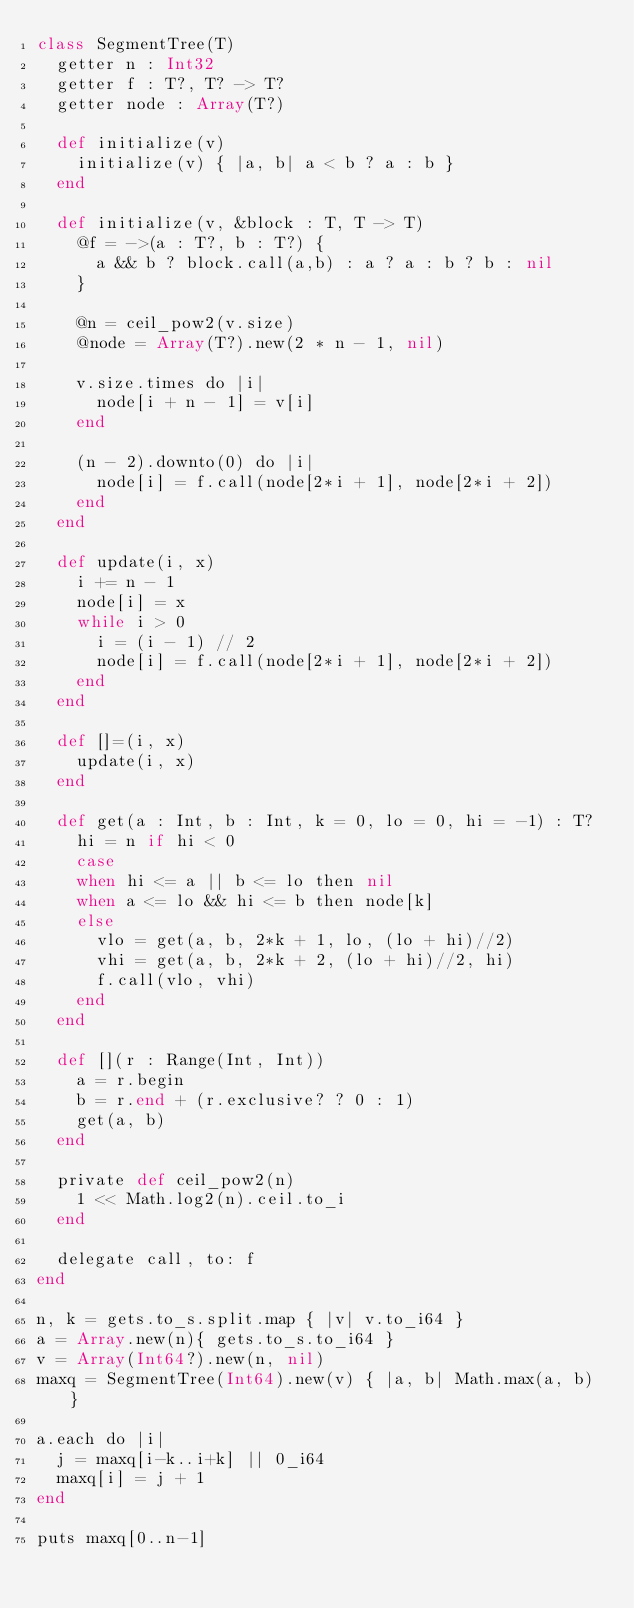Convert code to text. <code><loc_0><loc_0><loc_500><loc_500><_Crystal_>class SegmentTree(T)
  getter n : Int32
  getter f : T?, T? -> T?
  getter node : Array(T?)

  def initialize(v)
    initialize(v) { |a, b| a < b ? a : b }
  end

  def initialize(v, &block : T, T -> T)
    @f = ->(a : T?, b : T?) {
      a && b ? block.call(a,b) : a ? a : b ? b : nil
    }

    @n = ceil_pow2(v.size)
    @node = Array(T?).new(2 * n - 1, nil)

    v.size.times do |i|
      node[i + n - 1] = v[i]
    end

    (n - 2).downto(0) do |i|
      node[i] = f.call(node[2*i + 1], node[2*i + 2])
    end
  end

  def update(i, x)
    i += n - 1
    node[i] = x
    while i > 0
      i = (i - 1) // 2
      node[i] = f.call(node[2*i + 1], node[2*i + 2])
    end
  end

  def []=(i, x)
    update(i, x)
  end

  def get(a : Int, b : Int, k = 0, lo = 0, hi = -1) : T?
    hi = n if hi < 0
    case
    when hi <= a || b <= lo then nil
    when a <= lo && hi <= b then node[k]
    else
      vlo = get(a, b, 2*k + 1, lo, (lo + hi)//2)
      vhi = get(a, b, 2*k + 2, (lo + hi)//2, hi)
      f.call(vlo, vhi)
    end
  end

  def [](r : Range(Int, Int))
    a = r.begin
    b = r.end + (r.exclusive? ? 0 : 1)
    get(a, b)
  end

  private def ceil_pow2(n)
    1 << Math.log2(n).ceil.to_i
  end

  delegate call, to: f
end

n, k = gets.to_s.split.map { |v| v.to_i64 }
a = Array.new(n){ gets.to_s.to_i64 }
v = Array(Int64?).new(n, nil)
maxq = SegmentTree(Int64).new(v) { |a, b| Math.max(a, b) }

a.each do |i|
  j = maxq[i-k..i+k] || 0_i64
  maxq[i] = j + 1
end

puts maxq[0..n-1]</code> 